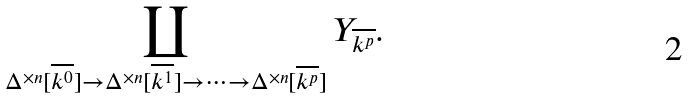Convert formula to latex. <formula><loc_0><loc_0><loc_500><loc_500>\coprod _ { \Delta ^ { \times n } [ \overline { k ^ { 0 } } ] \rightarrow \Delta ^ { \times n } [ \overline { k ^ { 1 } } ] \rightarrow \cdots \rightarrow \Delta ^ { \times n } [ \overline { k ^ { p } } ] } Y _ { \overline { k ^ { p } } } .</formula> 